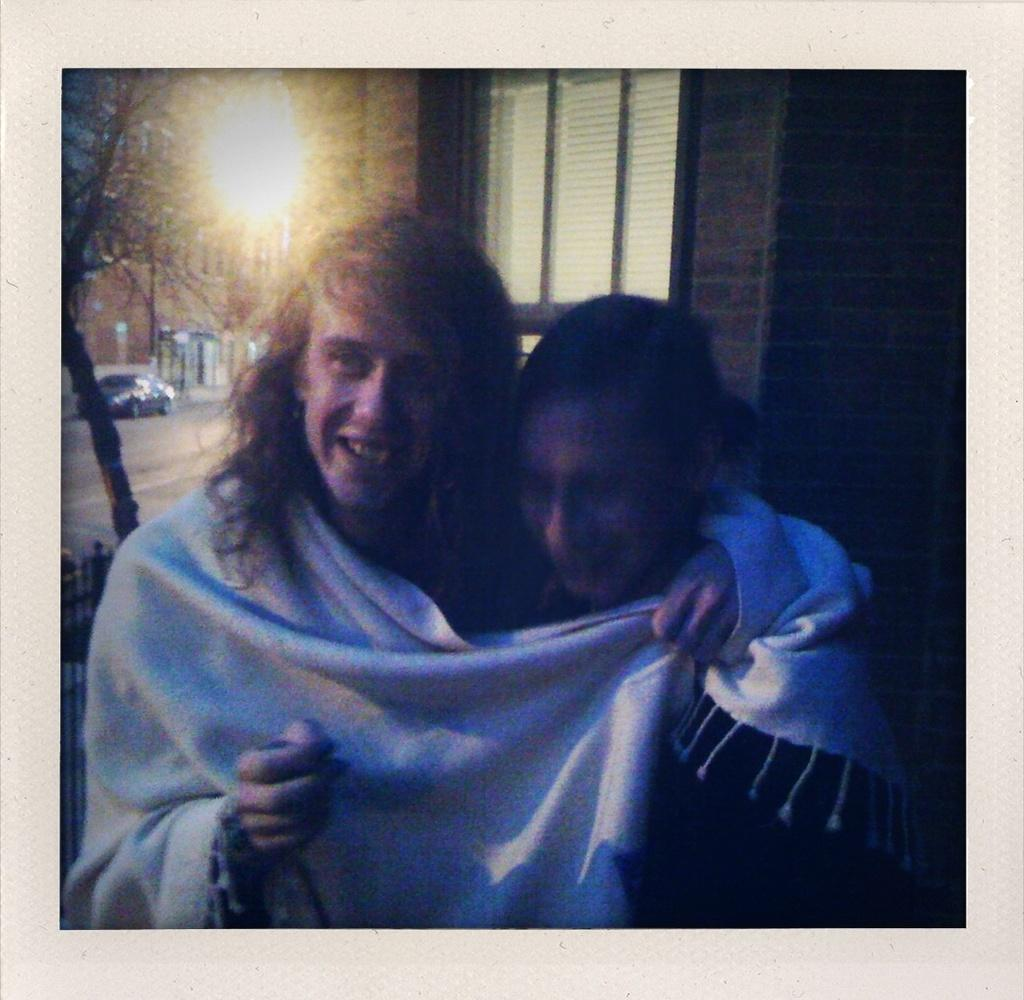How many people are in the image? There are two people in the image. What expression do the people have? The people are smiling. What can be seen in the background of the image? There is a building, a vehicle, and trees in the background of the image. What type of collar can be seen on the toy in the image? There is no toy or collar present in the image. 